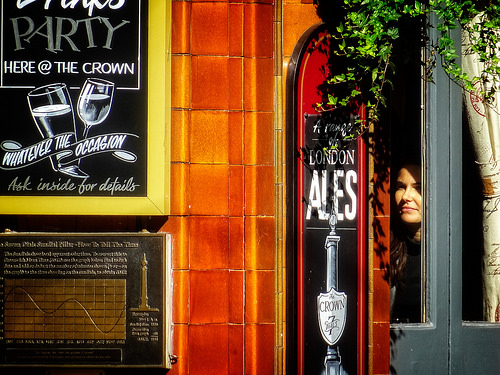<image>
Can you confirm if the lady is in front of the sign? No. The lady is not in front of the sign. The spatial positioning shows a different relationship between these objects. 